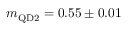<formula> <loc_0><loc_0><loc_500><loc_500>m _ { Q D 2 } = 0 . 5 5 \pm 0 . 0 1</formula> 